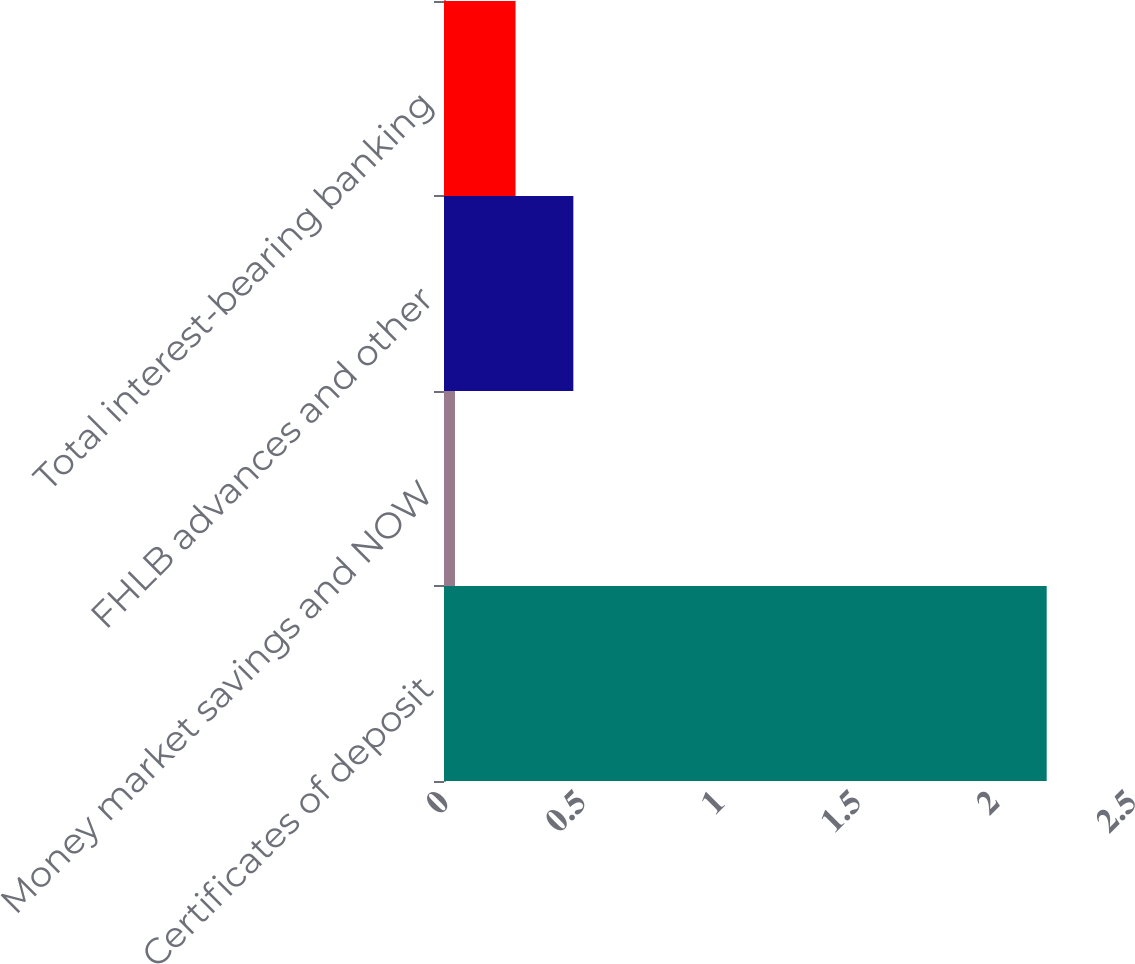Convert chart to OTSL. <chart><loc_0><loc_0><loc_500><loc_500><bar_chart><fcel>Certificates of deposit<fcel>Money market savings and NOW<fcel>FHLB advances and other<fcel>Total interest-bearing banking<nl><fcel>2.19<fcel>0.04<fcel>0.47<fcel>0.26<nl></chart> 